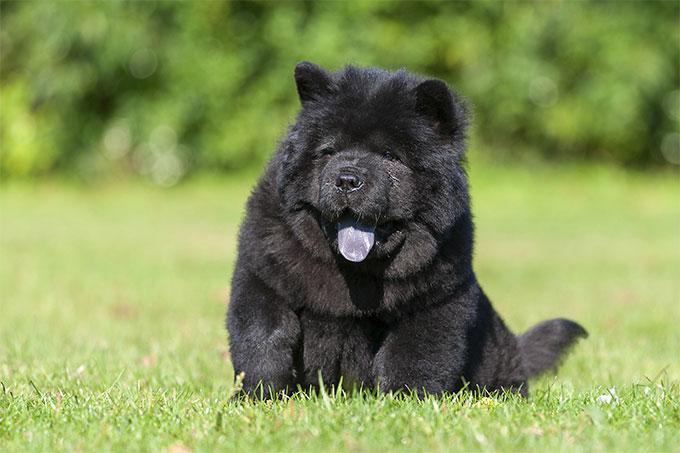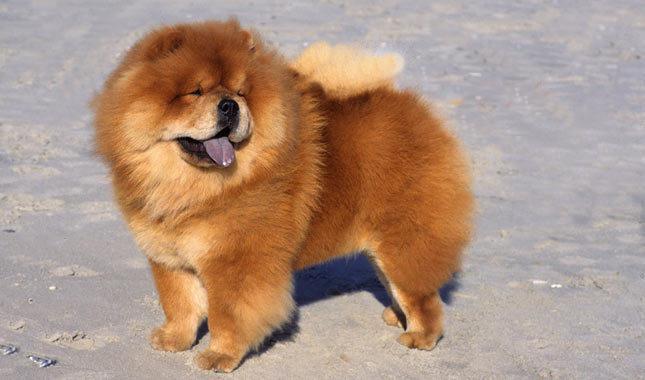The first image is the image on the left, the second image is the image on the right. Given the left and right images, does the statement "There are two chow chows outside in the grass." hold true? Answer yes or no. No. The first image is the image on the left, the second image is the image on the right. Evaluate the accuracy of this statement regarding the images: "There is one fluffy Chow Chow standing, and one fluffy Chow Chow with its face resting on the ground.". Is it true? Answer yes or no. No. 